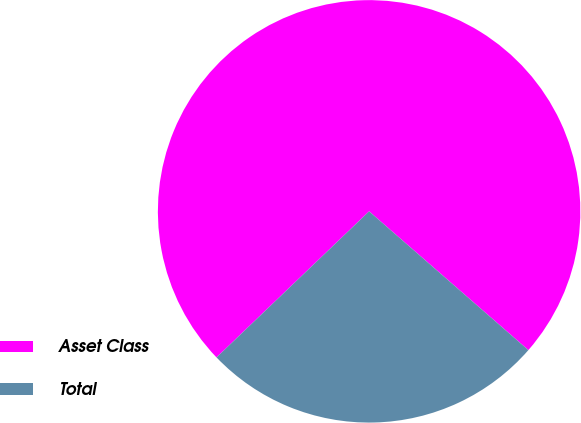Convert chart to OTSL. <chart><loc_0><loc_0><loc_500><loc_500><pie_chart><fcel>Asset Class<fcel>Total<nl><fcel>73.56%<fcel>26.44%<nl></chart> 